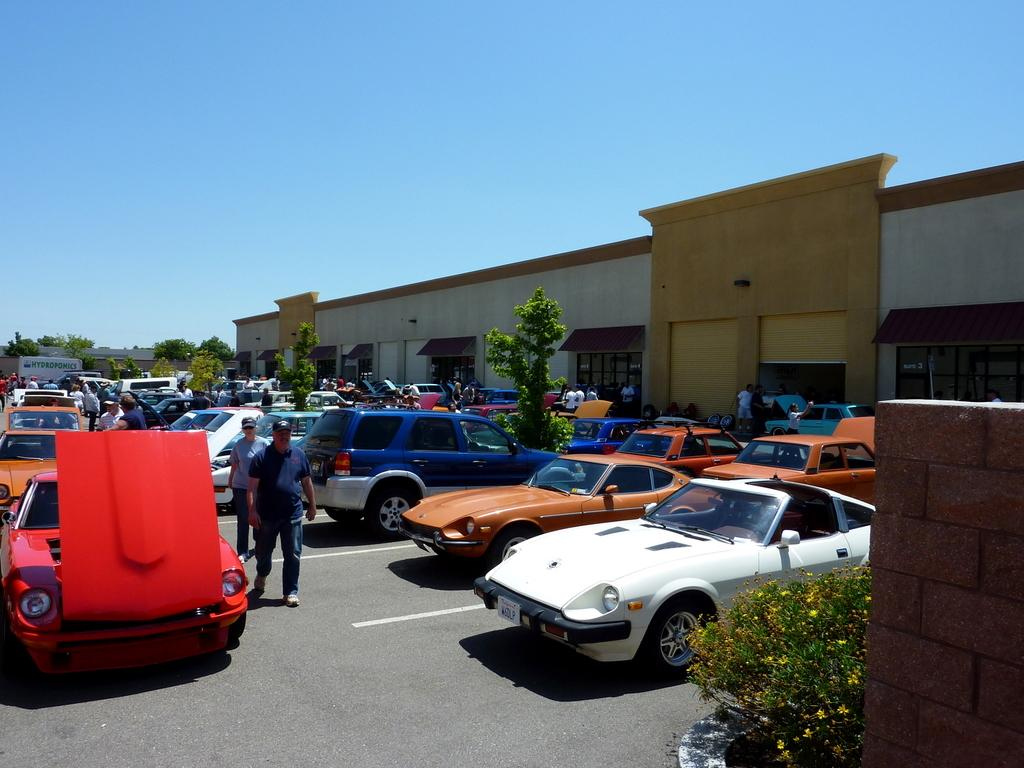What can be found in the parking slots in the image? There are motor vehicles in the parking slots. What are the people in the image doing? There are persons walking on the road in the image. What type of vegetation is present in the image? There are trees and bushes in the image. What structures can be seen in the image? There are buildings in the image. What part of the natural environment is visible in the image? The sky is visible in the image. What type of science experiment can be seen being conducted in the image? There is no science experiment present in the image; it features motor vehicles, persons walking, trees, bushes, buildings, and the sky. What type of bean is growing on the trees in the image? There are no beans growing on the trees in the image; it features trees and bushes as vegetation. 